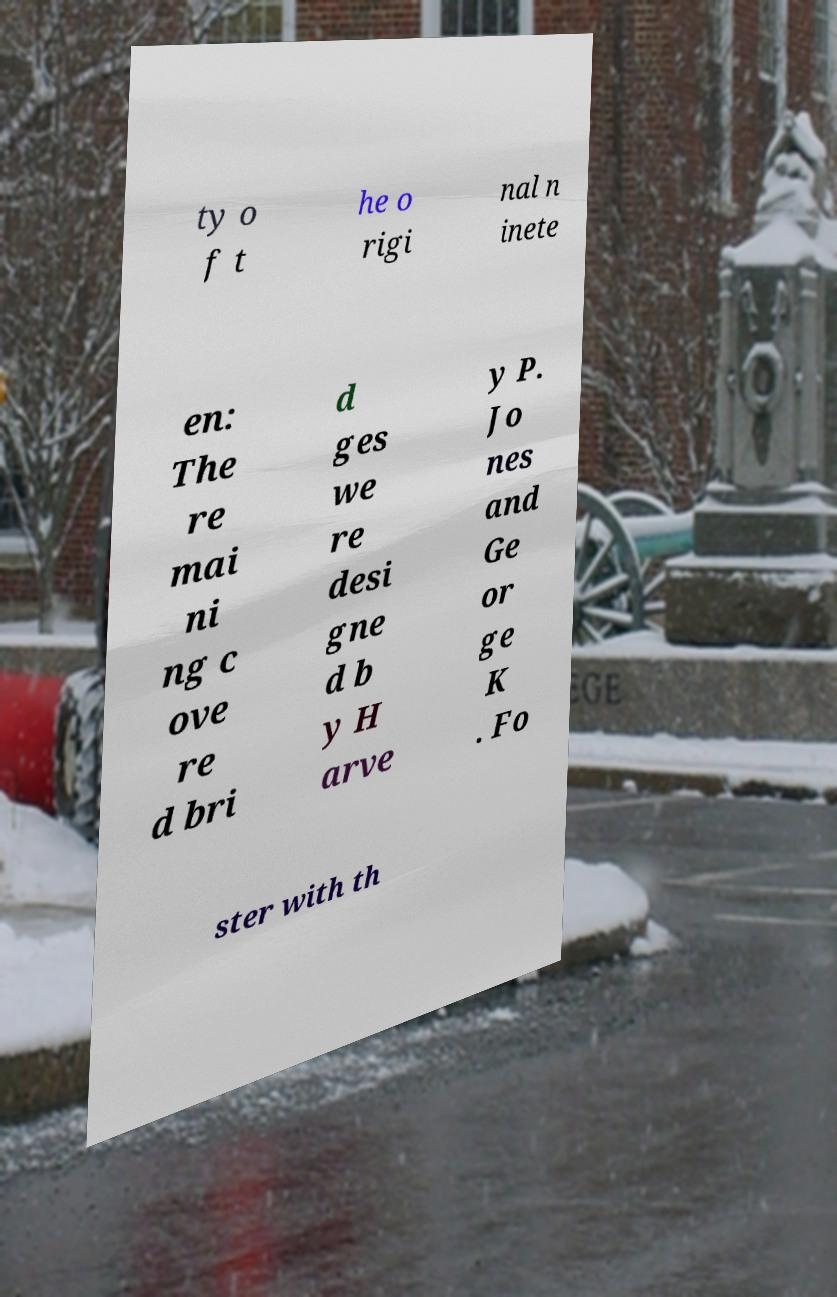Can you accurately transcribe the text from the provided image for me? ty o f t he o rigi nal n inete en: The re mai ni ng c ove re d bri d ges we re desi gne d b y H arve y P. Jo nes and Ge or ge K . Fo ster with th 